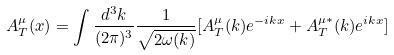<formula> <loc_0><loc_0><loc_500><loc_500>A _ { T } ^ { \mu } ( x ) = \int \frac { d ^ { 3 } k } { ( 2 \pi ) ^ { 3 } } \frac { 1 } { \sqrt { 2 \omega ( k ) } } [ A _ { T } ^ { \mu } ( k ) e ^ { - i k x } + A _ { T } ^ { \mu * } ( k ) e ^ { i k x } ]</formula> 